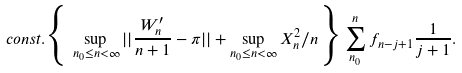Convert formula to latex. <formula><loc_0><loc_0><loc_500><loc_500>c o n s t . \Big { \{ } \sup _ { n _ { 0 } \leq n < \infty } | | \frac { W _ { n } ^ { \prime } } { n + 1 } - \pi | | + \sup _ { n _ { 0 } \leq n < \infty } X _ { n } ^ { 2 } / n \Big { \} } \sum _ { n _ { 0 } } ^ { n } f _ { n - j + 1 } \frac { 1 } { j + 1 } .</formula> 